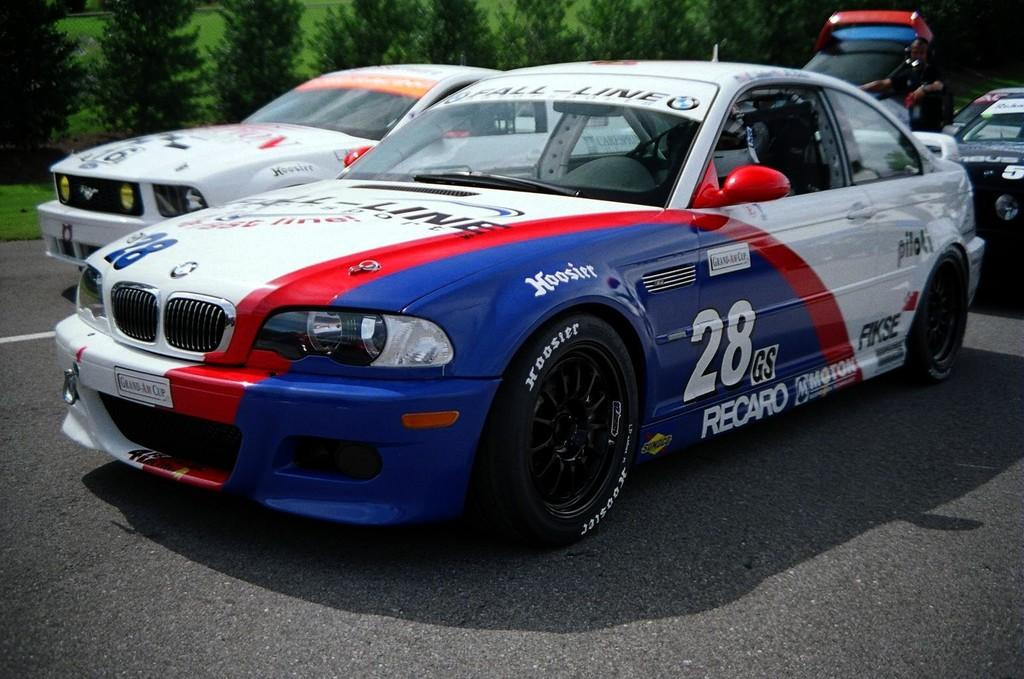What type of vehicles can be seen on the road in the image? There are cars on the road in the image. Can you describe the colors of the cars? There is a blue car, a red car, and a white car in the image. What is visible in the background of the image? There are trees in the background of the image. Where is the yak grazing in the image? There is no yak present in the image. What type of loss is depicted in the image? There is no loss depicted in the image; it features cars on the road and trees in the background. 